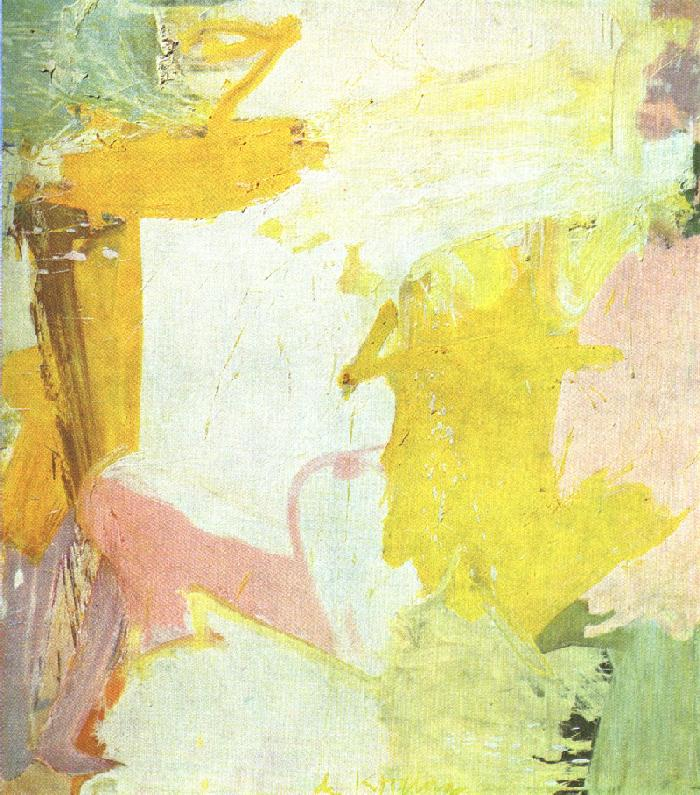If you could title this artwork, what would it be? I would title this artwork 'Whispers of Dawn'. The soft, pastel colors and the fluid nature of the brushstrokes evoke the gentle whispers and subtle hues of early morning light breaking the dawn. 